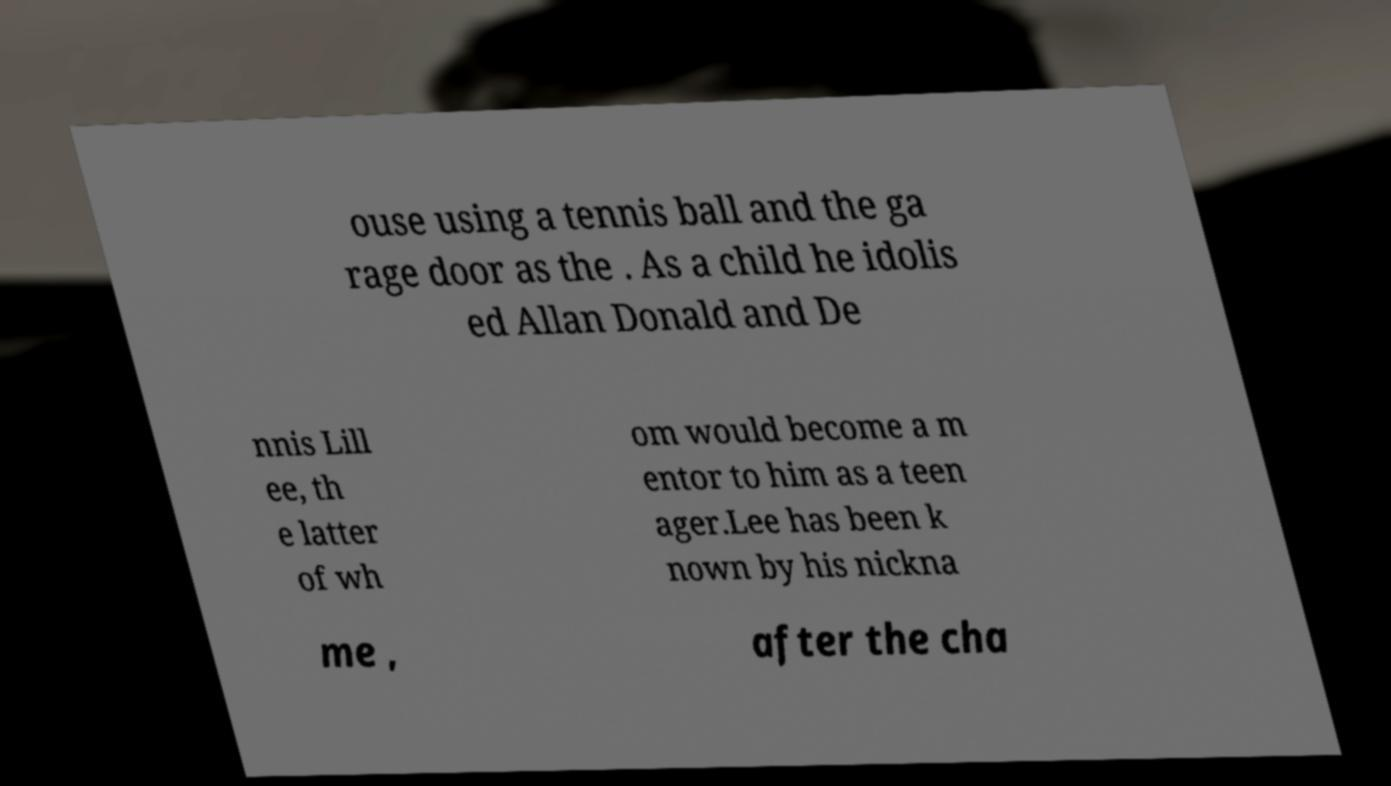Please read and relay the text visible in this image. What does it say? ouse using a tennis ball and the ga rage door as the . As a child he idolis ed Allan Donald and De nnis Lill ee, th e latter of wh om would become a m entor to him as a teen ager.Lee has been k nown by his nickna me , after the cha 